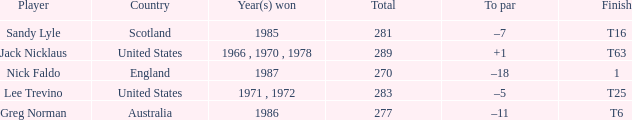What player has 1 as the place? Nick Faldo. 